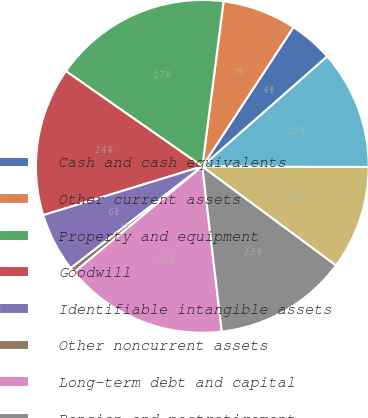Convert chart. <chart><loc_0><loc_0><loc_500><loc_500><pie_chart><fcel>Cash and cash equivalents<fcel>Other current assets<fcel>Property and equipment<fcel>Goodwill<fcel>Identifiable intangible assets<fcel>Other noncurrent assets<fcel>Long-term debt and capital<fcel>Pension and postretirement<fcel>Air traffic liability and<fcel>Other liabilities assumed<nl><fcel>4.29%<fcel>7.19%<fcel>17.34%<fcel>14.44%<fcel>5.74%<fcel>0.51%<fcel>15.89%<fcel>12.99%<fcel>10.09%<fcel>11.54%<nl></chart> 